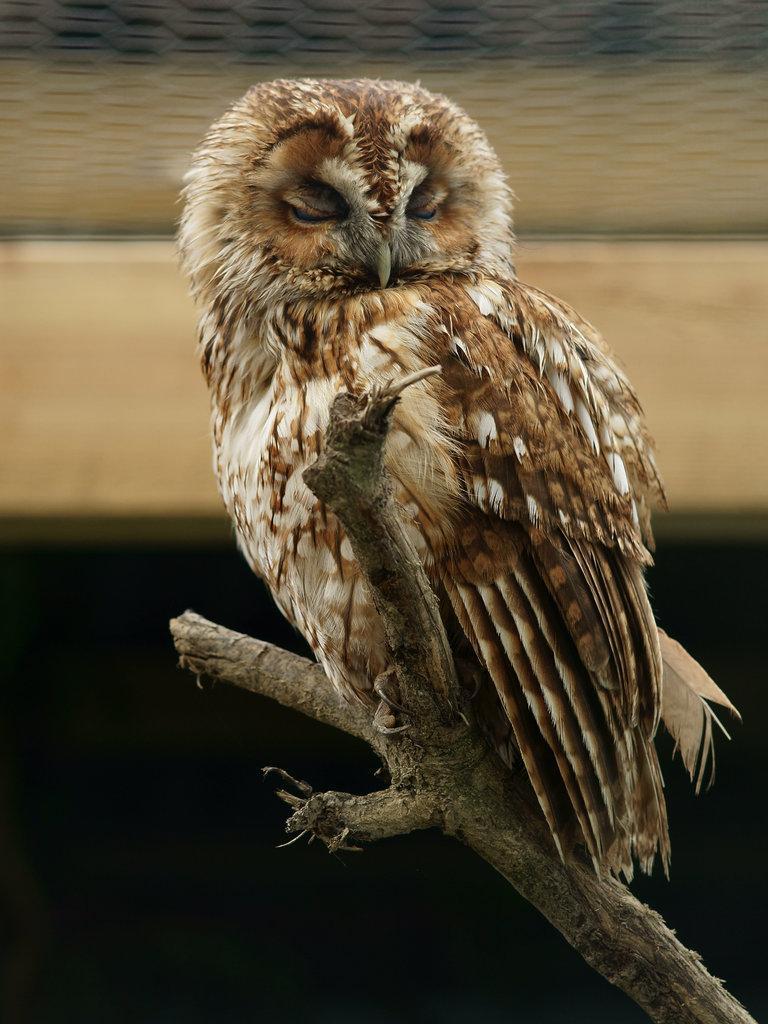Could you give a brief overview of what you see in this image? In this image there is an owl on a steam, in the background it is blurred. 